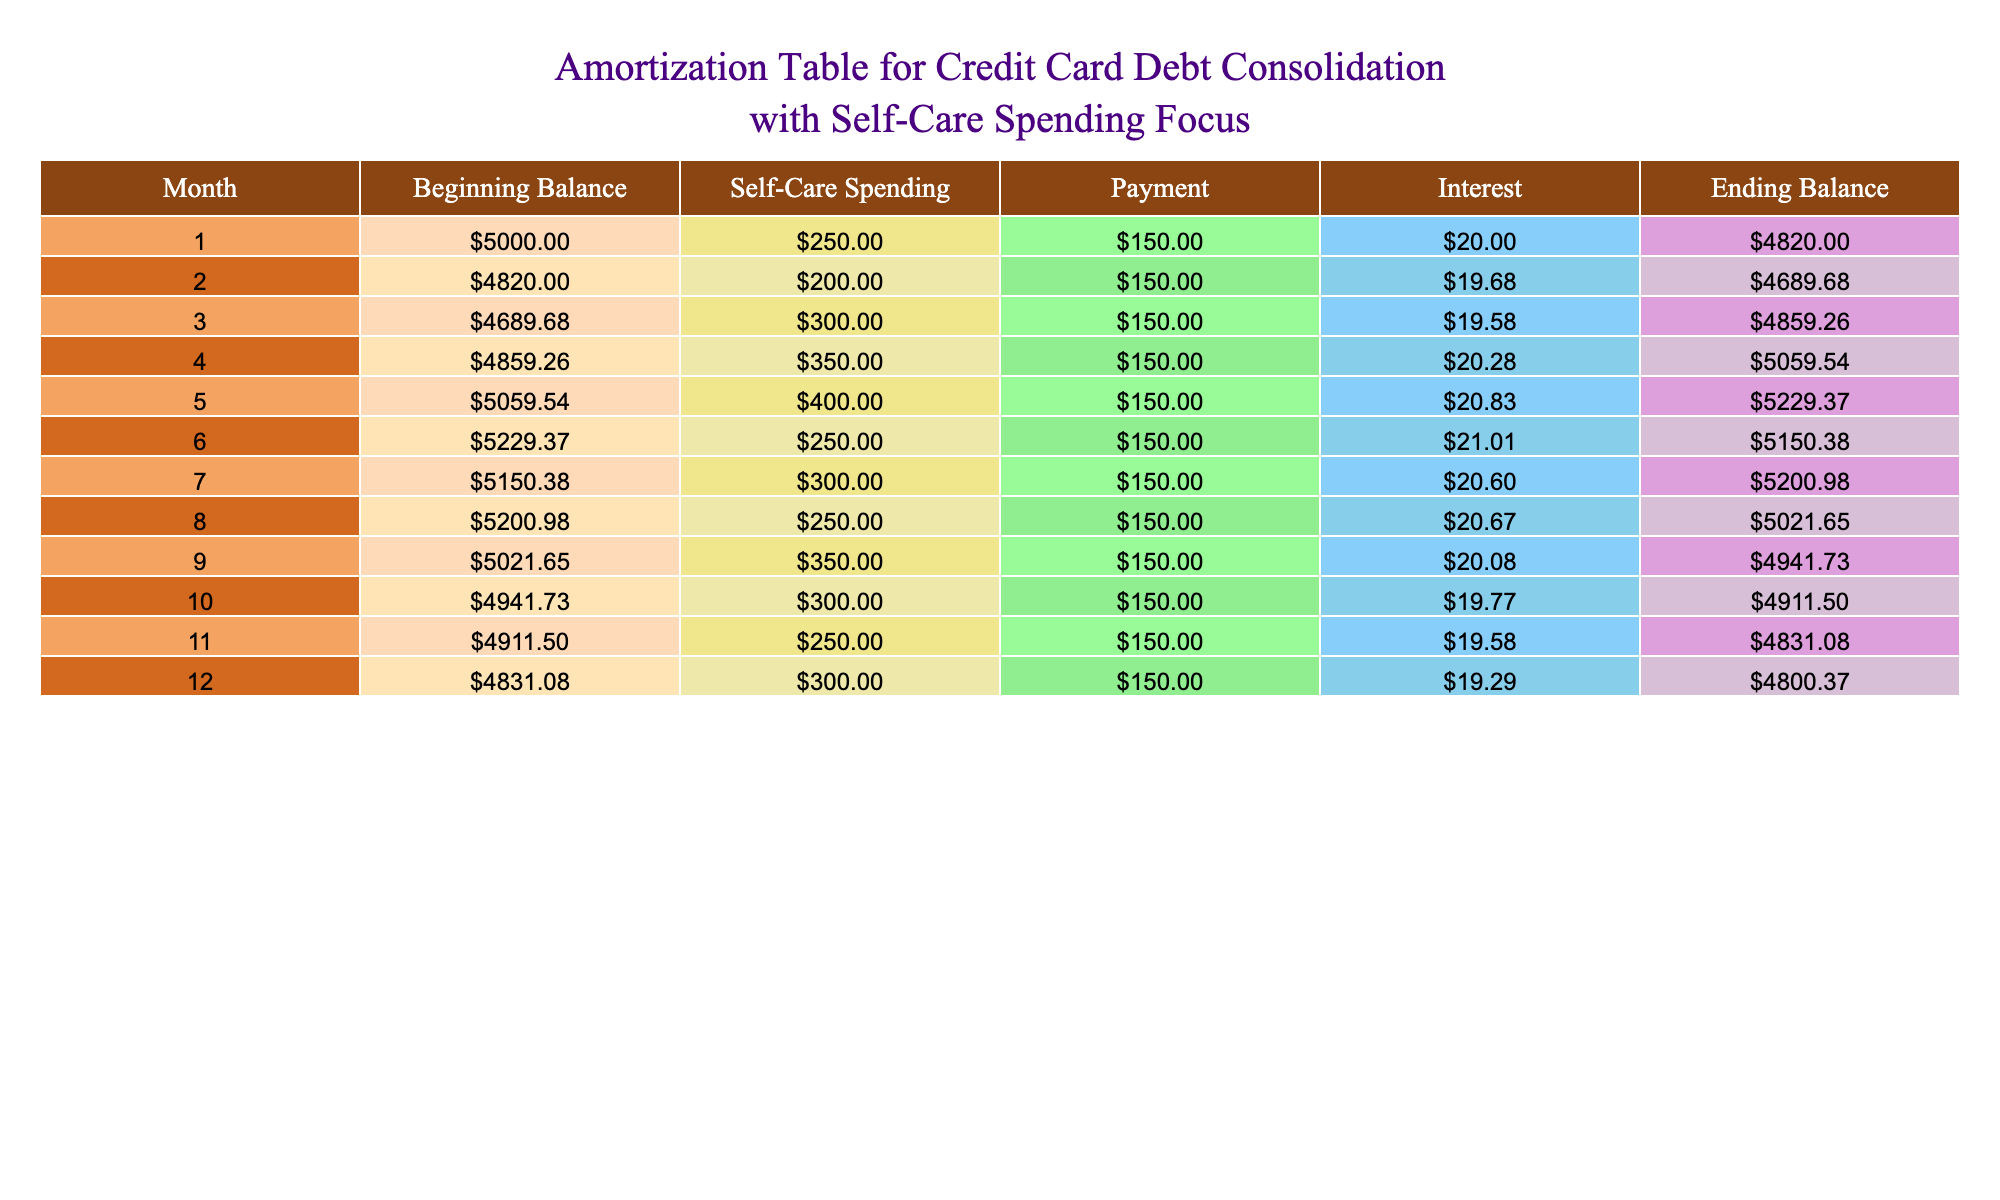What was the beginning balance in the first month? Looking at the table, the "Beginning Balance" for the first month is the first value listed under that column, which is 5000.
Answer: 5000 What is the total self-care spending over the 12 months? To find the total self-care spending, we add up all the values in the "Self-Care Spending" column: 250 + 200 + 300 + 350 + 400 + 250 + 300 + 250 + 350 + 300 + 250 + 300 = 3850.
Answer: 3850 Did the ending balance decrease every month? By examining the "Ending Balance" column, I check each month if the value is consistently lower than the previous month. I notice that in month 3 (4859.26), the ending balance increases to 5059.54 in month 4, meaning it did not decrease every month.
Answer: No What is the average payment made per month? To calculate the average payment per month, sum the payments across all months (150 * 12 = 1800) and then divide by the number of months (12), resulting in an average payment of 150.
Answer: 150 What was the highest ending balance recorded in the table? The highest value in the "Ending Balance" column must be identified by comparing all the ending balances listed. The maximum value appears to be 5229.37 in month 5.
Answer: 5229.37 In which month did self-care spending peak? By inspecting the "Self-Care Spending" column, we find the maximum value is 400, which occurs in month 5.
Answer: Month 5 What was the total interest paid throughout the 12 months? The total interest is calculated by adding all the values in the "Interest" column: 20 + 19.68 + 19.58 + 20.28 + 20.83 + 21.01 + 20.60 + 20.67 + 20.08 + 19.77 + 19.58 + 19.29 = 242.61.
Answer: 242.61 Was there a month where the ending balance was below 4900? To answer this question, I will check each month's ending balance to see if any values fall below 4900. Upon reviewing the table, months 1, 2, 3, and 4 do meet this criterion.
Answer: Yes How much did the ending balance change from month 6 to month 7? To find the change between months 6 and 7, I subtract the ending balance of month 6 from month 7: 5200.98 (month 7) - 5150.38 (month 6) = 50.60.
Answer: 50.60 